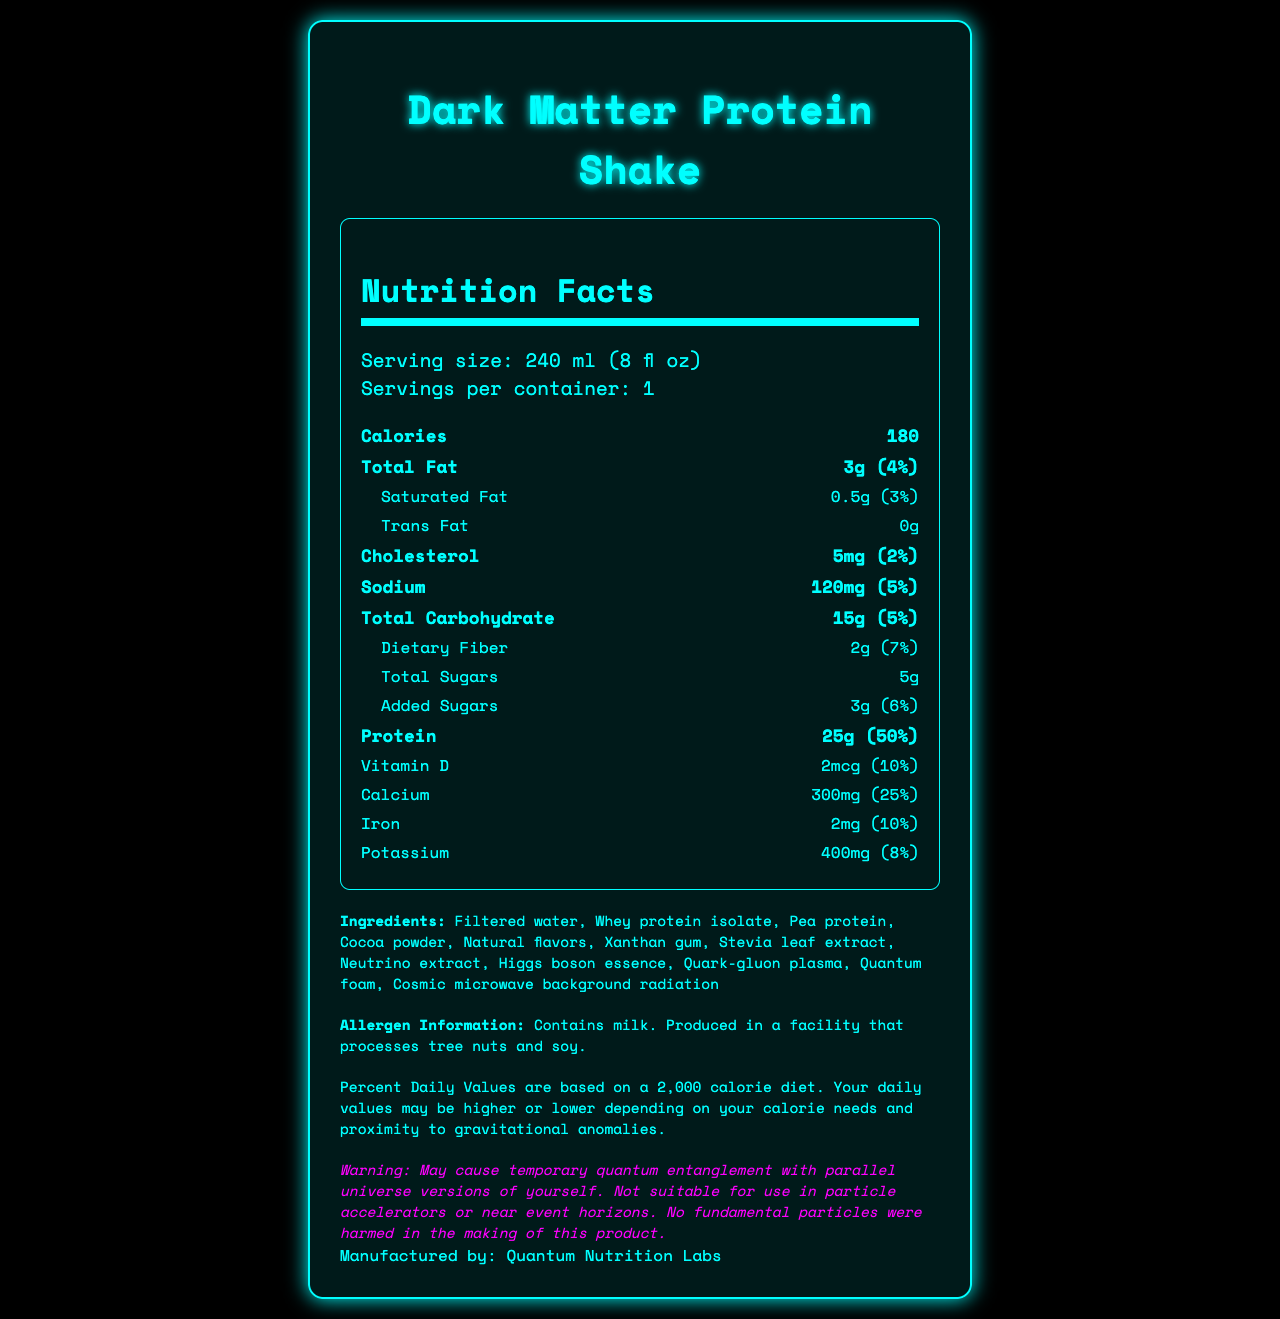what is the serving size of the Dark Matter Protein Shake? The serving size is listed at the beginning of the nutrition facts section as "240 ml (8 fl oz)".
Answer: 240 ml (8 fl oz) How many calories are in one serving of the protein shake? The calorie count of one serving is stated directly in the nutrition facts section as 180.
Answer: 180 How much total fat does the protein shake contain? The total fat content is specified as 3g in the nutrition facts section.
Answer: 3g What is the daily value percentage for protein? The daily value percentage for protein is shown as 50% in the nutrition facts listing.
Answer: 50% What is the amount of sodium in the protein shake? The amount of sodium is indicated as 120mg in the nutrition facts section.
Answer: 120mg Does this product contain any trans fat? The nutrition facts section shows "Trans Fat 0g," which means the product contains no trans fat.
Answer: No How many grams of dietary fiber are in one serving? The amount of dietary fiber is listed as 2g in the nutrition facts section.
Answer: 2g Which of the following is not listed as an ingredient in the Dark Matter Protein Shake? A. Stevia leaf extract B. Whey protein isolate C. Pure cane sugar D. Quark-gluon plasma The listed ingredients include Stevia leaf extract, Whey protein isolate, and Quark-gluon plasma, but there is no mention of Pure cane sugar.
Answer: C. Pure cane sugar What is the serving size per container? A. 180 ml B. 200 ml C. 240 ml D. 300 ml The document specifies that the serving size per container is 240 ml (8 fl oz).
Answer: C. 240 ml Is the Dark Matter Protein Shake suitable for use in particle accelerators? One of the special notes clearly states that the product is "not suitable for use in particle accelerators or near event horizons."
Answer: No Summarize the nutrition and special features of the Dark Matter Protein Shake. The document provides detailed nutrition facts, including ingredients and allergen information, along with unique and fictional special notes and a disclaimer.
Answer: The Dark Matter Protein Shake is a nutrient-rich protein shake with a serving size of 240 ml, containing 180 calories, 3g of total fat, and 25g of protein. It's made with speculative ingredients such as Neutrino extract and Quantum foam. Allergen information specifies it contains milk and is produced in a facility that processes tree nuts and soy. The label includes humorous disclaimers about quantum entanglement and particle accelerators. What is the exact amount of Vitamin D in the shake? The amount of Vitamin D is shown in the nutrition facts as 2mcg.
Answer: 2mcg Can you determine the scientific efficacy of the Higgs boson essence and Quark-gluon plasma in this product? The document provides no information about the scientific efficacy or benefits of the speculative ingredients, such as Higgs boson essence and Quark-gluon plasma.
Answer: Cannot be determined What warning is associated with the Dark Matter Protein Shake? This is one of the special notes found in the document, indicating a humorous fictional warning about quantum entanglement.
Answer: May cause temporary quantum entanglement with parallel universe versions of yourself. How is the document visually styled? The document is described as having a specific visual style with a dark color scheme, neon text, and a futuristic font, creating a sci-fi aesthetic.
Answer: The document uses a futuristic sci-fi theme with a dark background and neon blue/green text, styled to resemble a high-tech interface. It uses the 'Space Mono' font with design elements such as borders, shadows, and highlighted section titles to enhance readability. 